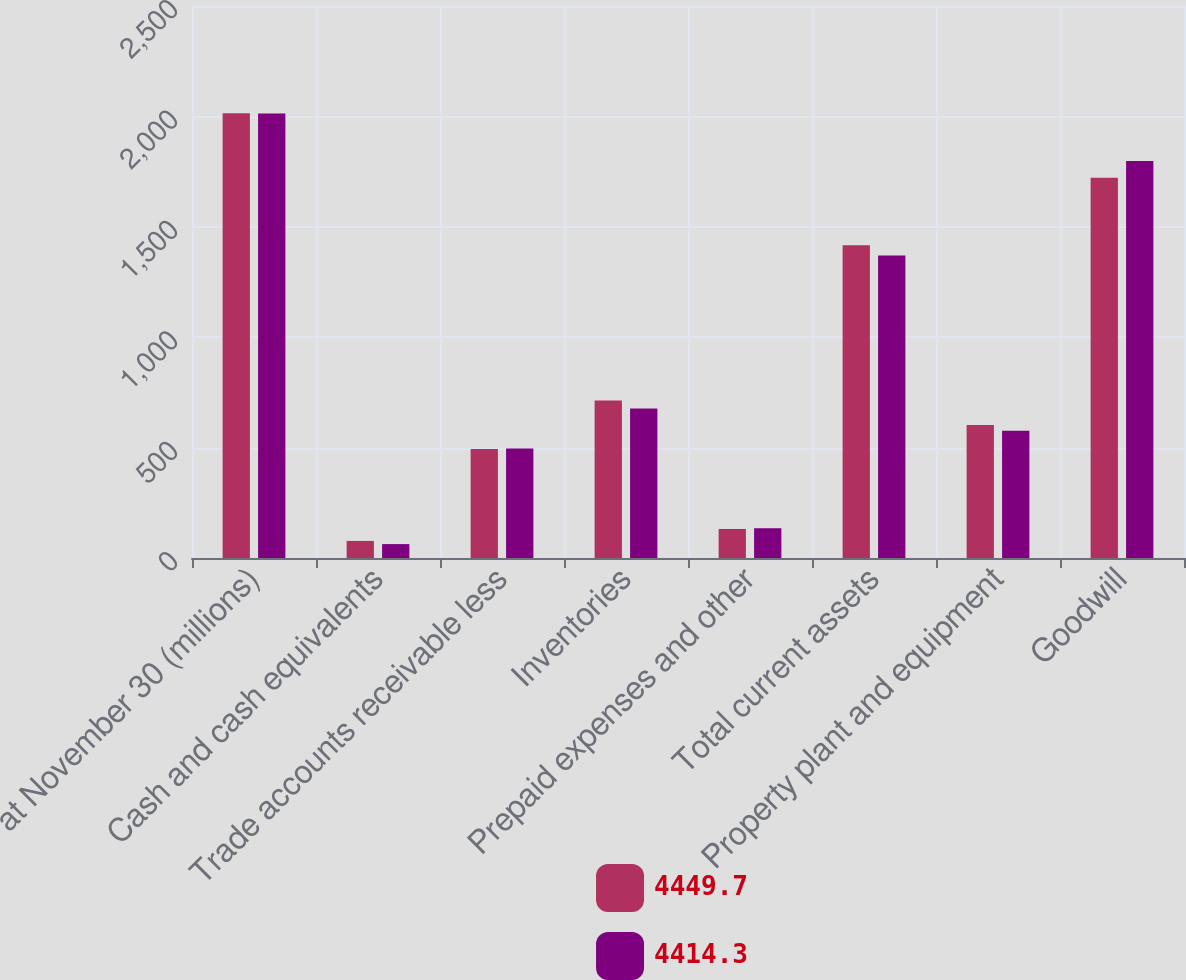Convert chart. <chart><loc_0><loc_0><loc_500><loc_500><stacked_bar_chart><ecel><fcel>at November 30 (millions)<fcel>Cash and cash equivalents<fcel>Trade accounts receivable less<fcel>Inventories<fcel>Prepaid expenses and other<fcel>Total current assets<fcel>Property plant and equipment<fcel>Goodwill<nl><fcel>4449.7<fcel>2014<fcel>77.3<fcel>493.6<fcel>713.8<fcel>131.5<fcel>1416.2<fcel>602.7<fcel>1722.2<nl><fcel>4414.3<fcel>2013<fcel>63<fcel>495.5<fcel>676.9<fcel>134.8<fcel>1370.2<fcel>576.6<fcel>1798.5<nl></chart> 